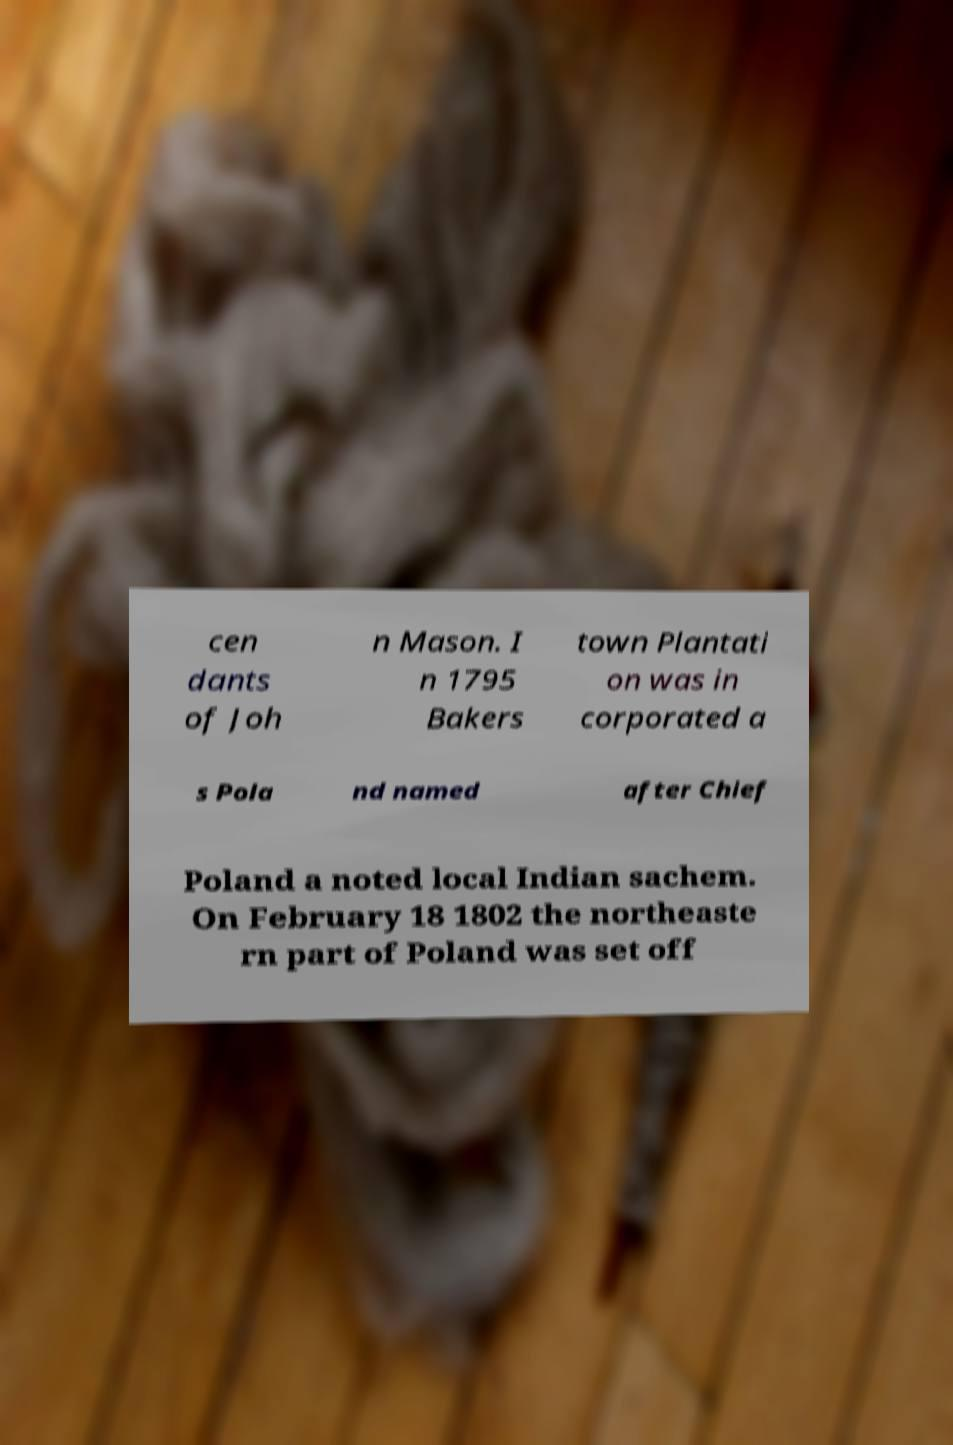Could you extract and type out the text from this image? cen dants of Joh n Mason. I n 1795 Bakers town Plantati on was in corporated a s Pola nd named after Chief Poland a noted local Indian sachem. On February 18 1802 the northeaste rn part of Poland was set off 